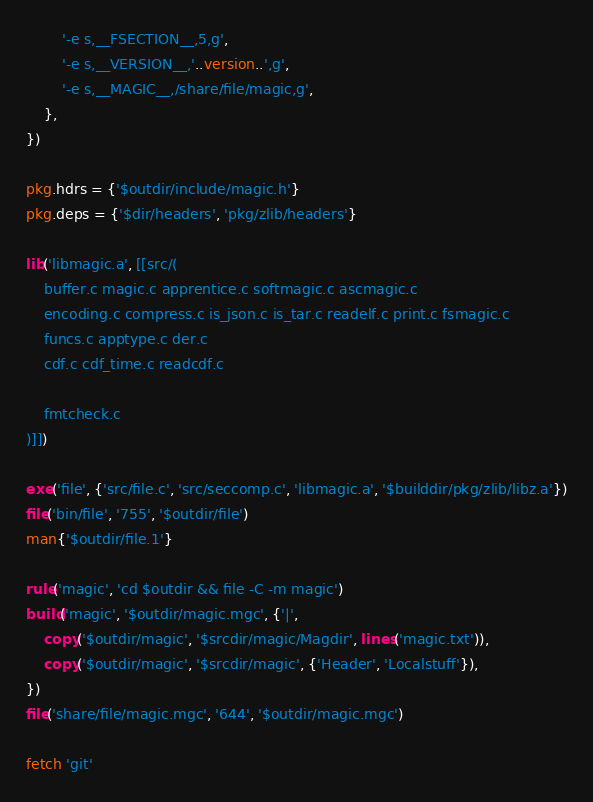Convert code to text. <code><loc_0><loc_0><loc_500><loc_500><_Lua_>		'-e s,__FSECTION__,5,g',
		'-e s,__VERSION__,'..version..',g',
		'-e s,__MAGIC__,/share/file/magic,g',
	},
})

pkg.hdrs = {'$outdir/include/magic.h'}
pkg.deps = {'$dir/headers', 'pkg/zlib/headers'}

lib('libmagic.a', [[src/(
	buffer.c magic.c apprentice.c softmagic.c ascmagic.c
	encoding.c compress.c is_json.c is_tar.c readelf.c print.c fsmagic.c
	funcs.c apptype.c der.c
	cdf.c cdf_time.c readcdf.c

	fmtcheck.c
)]])

exe('file', {'src/file.c', 'src/seccomp.c', 'libmagic.a', '$builddir/pkg/zlib/libz.a'})
file('bin/file', '755', '$outdir/file')
man{'$outdir/file.1'}

rule('magic', 'cd $outdir && file -C -m magic')
build('magic', '$outdir/magic.mgc', {'|',
	copy('$outdir/magic', '$srcdir/magic/Magdir', lines('magic.txt')),
	copy('$outdir/magic', '$srcdir/magic', {'Header', 'Localstuff'}),
})
file('share/file/magic.mgc', '644', '$outdir/magic.mgc')

fetch 'git'
</code> 